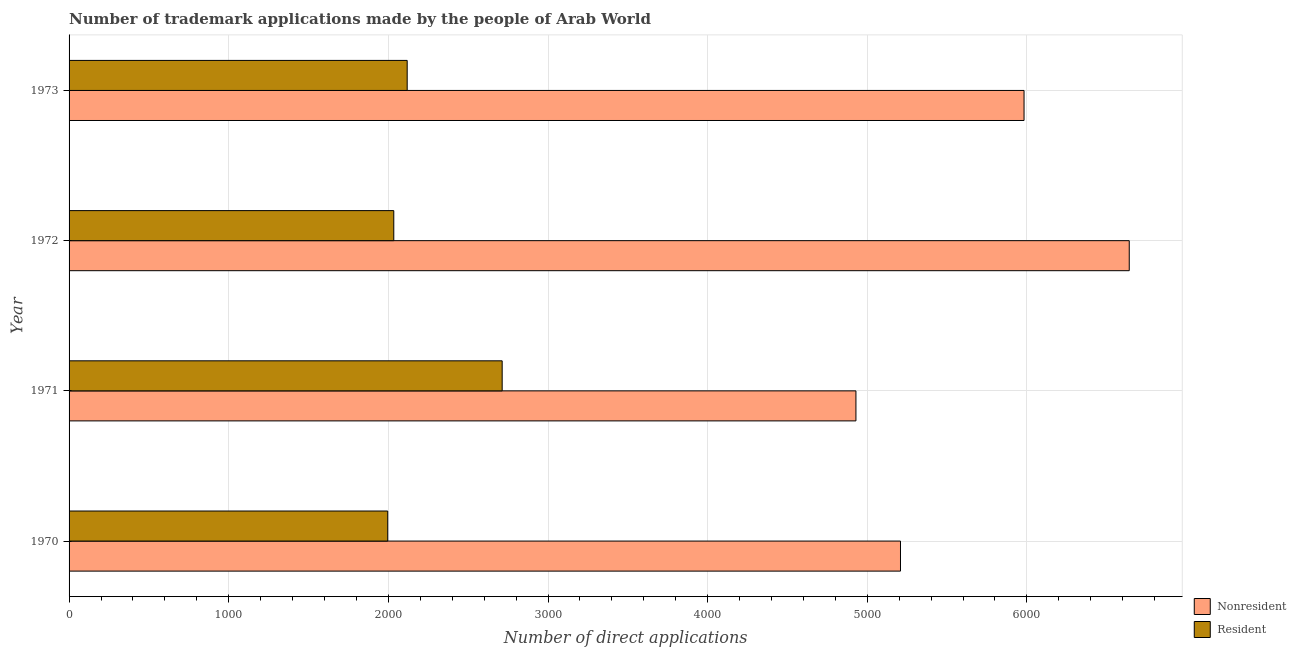Are the number of bars on each tick of the Y-axis equal?
Keep it short and to the point. Yes. How many bars are there on the 3rd tick from the top?
Offer a terse response. 2. How many bars are there on the 2nd tick from the bottom?
Ensure brevity in your answer.  2. In how many cases, is the number of bars for a given year not equal to the number of legend labels?
Give a very brief answer. 0. What is the number of trademark applications made by non residents in 1973?
Your answer should be compact. 5982. Across all years, what is the maximum number of trademark applications made by residents?
Keep it short and to the point. 2713. Across all years, what is the minimum number of trademark applications made by residents?
Provide a succinct answer. 1996. In which year was the number of trademark applications made by non residents maximum?
Your answer should be very brief. 1972. What is the total number of trademark applications made by residents in the graph?
Ensure brevity in your answer.  8861. What is the difference between the number of trademark applications made by residents in 1970 and that in 1971?
Your response must be concise. -717. What is the difference between the number of trademark applications made by non residents in 1972 and the number of trademark applications made by residents in 1970?
Ensure brevity in your answer.  4645. What is the average number of trademark applications made by non residents per year?
Offer a very short reply. 5690. In the year 1970, what is the difference between the number of trademark applications made by non residents and number of trademark applications made by residents?
Provide a short and direct response. 3212. In how many years, is the number of trademark applications made by residents greater than 2200 ?
Make the answer very short. 1. Is the number of trademark applications made by non residents in 1970 less than that in 1973?
Your response must be concise. Yes. Is the difference between the number of trademark applications made by non residents in 1970 and 1973 greater than the difference between the number of trademark applications made by residents in 1970 and 1973?
Your answer should be compact. No. What is the difference between the highest and the second highest number of trademark applications made by non residents?
Your answer should be compact. 659. What is the difference between the highest and the lowest number of trademark applications made by residents?
Keep it short and to the point. 717. What does the 2nd bar from the top in 1973 represents?
Your response must be concise. Nonresident. What does the 1st bar from the bottom in 1971 represents?
Provide a succinct answer. Nonresident. What is the difference between two consecutive major ticks on the X-axis?
Keep it short and to the point. 1000. Are the values on the major ticks of X-axis written in scientific E-notation?
Your answer should be very brief. No. Does the graph contain any zero values?
Make the answer very short. No. How many legend labels are there?
Ensure brevity in your answer.  2. What is the title of the graph?
Offer a very short reply. Number of trademark applications made by the people of Arab World. Does "Domestic liabilities" appear as one of the legend labels in the graph?
Ensure brevity in your answer.  No. What is the label or title of the X-axis?
Your answer should be compact. Number of direct applications. What is the label or title of the Y-axis?
Provide a short and direct response. Year. What is the Number of direct applications of Nonresident in 1970?
Provide a succinct answer. 5208. What is the Number of direct applications of Resident in 1970?
Keep it short and to the point. 1996. What is the Number of direct applications of Nonresident in 1971?
Ensure brevity in your answer.  4929. What is the Number of direct applications in Resident in 1971?
Give a very brief answer. 2713. What is the Number of direct applications of Nonresident in 1972?
Give a very brief answer. 6641. What is the Number of direct applications of Resident in 1972?
Give a very brief answer. 2034. What is the Number of direct applications in Nonresident in 1973?
Give a very brief answer. 5982. What is the Number of direct applications in Resident in 1973?
Ensure brevity in your answer.  2118. Across all years, what is the maximum Number of direct applications in Nonresident?
Ensure brevity in your answer.  6641. Across all years, what is the maximum Number of direct applications in Resident?
Provide a short and direct response. 2713. Across all years, what is the minimum Number of direct applications of Nonresident?
Your response must be concise. 4929. Across all years, what is the minimum Number of direct applications in Resident?
Provide a succinct answer. 1996. What is the total Number of direct applications in Nonresident in the graph?
Make the answer very short. 2.28e+04. What is the total Number of direct applications in Resident in the graph?
Your answer should be very brief. 8861. What is the difference between the Number of direct applications in Nonresident in 1970 and that in 1971?
Your answer should be compact. 279. What is the difference between the Number of direct applications of Resident in 1970 and that in 1971?
Provide a succinct answer. -717. What is the difference between the Number of direct applications of Nonresident in 1970 and that in 1972?
Provide a succinct answer. -1433. What is the difference between the Number of direct applications of Resident in 1970 and that in 1972?
Your answer should be very brief. -38. What is the difference between the Number of direct applications in Nonresident in 1970 and that in 1973?
Your answer should be compact. -774. What is the difference between the Number of direct applications of Resident in 1970 and that in 1973?
Ensure brevity in your answer.  -122. What is the difference between the Number of direct applications of Nonresident in 1971 and that in 1972?
Keep it short and to the point. -1712. What is the difference between the Number of direct applications in Resident in 1971 and that in 1972?
Give a very brief answer. 679. What is the difference between the Number of direct applications of Nonresident in 1971 and that in 1973?
Your answer should be compact. -1053. What is the difference between the Number of direct applications in Resident in 1971 and that in 1973?
Your response must be concise. 595. What is the difference between the Number of direct applications of Nonresident in 1972 and that in 1973?
Your answer should be very brief. 659. What is the difference between the Number of direct applications of Resident in 1972 and that in 1973?
Offer a very short reply. -84. What is the difference between the Number of direct applications of Nonresident in 1970 and the Number of direct applications of Resident in 1971?
Give a very brief answer. 2495. What is the difference between the Number of direct applications of Nonresident in 1970 and the Number of direct applications of Resident in 1972?
Keep it short and to the point. 3174. What is the difference between the Number of direct applications of Nonresident in 1970 and the Number of direct applications of Resident in 1973?
Make the answer very short. 3090. What is the difference between the Number of direct applications of Nonresident in 1971 and the Number of direct applications of Resident in 1972?
Keep it short and to the point. 2895. What is the difference between the Number of direct applications of Nonresident in 1971 and the Number of direct applications of Resident in 1973?
Give a very brief answer. 2811. What is the difference between the Number of direct applications in Nonresident in 1972 and the Number of direct applications in Resident in 1973?
Your answer should be very brief. 4523. What is the average Number of direct applications of Nonresident per year?
Keep it short and to the point. 5690. What is the average Number of direct applications of Resident per year?
Make the answer very short. 2215.25. In the year 1970, what is the difference between the Number of direct applications of Nonresident and Number of direct applications of Resident?
Provide a short and direct response. 3212. In the year 1971, what is the difference between the Number of direct applications in Nonresident and Number of direct applications in Resident?
Offer a very short reply. 2216. In the year 1972, what is the difference between the Number of direct applications of Nonresident and Number of direct applications of Resident?
Keep it short and to the point. 4607. In the year 1973, what is the difference between the Number of direct applications of Nonresident and Number of direct applications of Resident?
Keep it short and to the point. 3864. What is the ratio of the Number of direct applications in Nonresident in 1970 to that in 1971?
Keep it short and to the point. 1.06. What is the ratio of the Number of direct applications in Resident in 1970 to that in 1971?
Offer a terse response. 0.74. What is the ratio of the Number of direct applications in Nonresident in 1970 to that in 1972?
Your answer should be very brief. 0.78. What is the ratio of the Number of direct applications of Resident in 1970 to that in 1972?
Ensure brevity in your answer.  0.98. What is the ratio of the Number of direct applications in Nonresident in 1970 to that in 1973?
Your answer should be very brief. 0.87. What is the ratio of the Number of direct applications of Resident in 1970 to that in 1973?
Ensure brevity in your answer.  0.94. What is the ratio of the Number of direct applications in Nonresident in 1971 to that in 1972?
Make the answer very short. 0.74. What is the ratio of the Number of direct applications in Resident in 1971 to that in 1972?
Keep it short and to the point. 1.33. What is the ratio of the Number of direct applications in Nonresident in 1971 to that in 1973?
Your answer should be very brief. 0.82. What is the ratio of the Number of direct applications of Resident in 1971 to that in 1973?
Offer a terse response. 1.28. What is the ratio of the Number of direct applications of Nonresident in 1972 to that in 1973?
Your response must be concise. 1.11. What is the ratio of the Number of direct applications in Resident in 1972 to that in 1973?
Provide a short and direct response. 0.96. What is the difference between the highest and the second highest Number of direct applications in Nonresident?
Keep it short and to the point. 659. What is the difference between the highest and the second highest Number of direct applications of Resident?
Provide a succinct answer. 595. What is the difference between the highest and the lowest Number of direct applications in Nonresident?
Keep it short and to the point. 1712. What is the difference between the highest and the lowest Number of direct applications in Resident?
Your response must be concise. 717. 